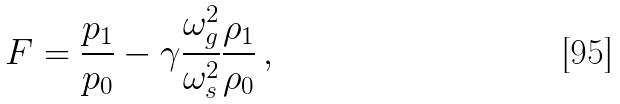Convert formula to latex. <formula><loc_0><loc_0><loc_500><loc_500>F = \frac { p _ { 1 } } { p _ { 0 } } - \gamma \frac { \omega _ { g } ^ { 2 } } { \omega _ { s } ^ { 2 } } \frac { \rho _ { 1 } } { \rho _ { 0 } } \, ,</formula> 